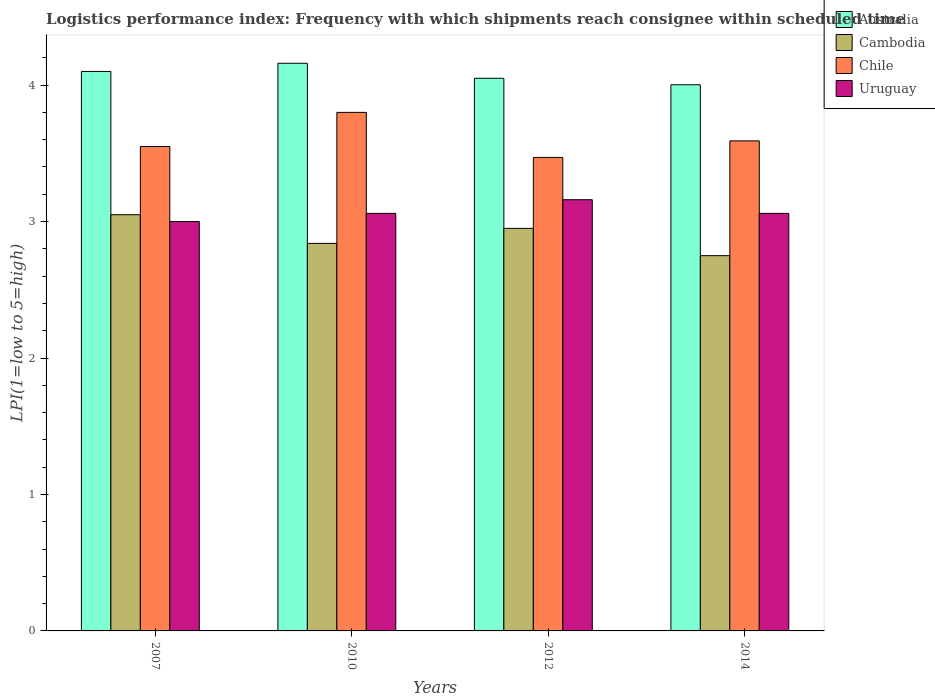How many groups of bars are there?
Provide a short and direct response. 4. Are the number of bars per tick equal to the number of legend labels?
Give a very brief answer. Yes. How many bars are there on the 1st tick from the left?
Your answer should be compact. 4. What is the logistics performance index in Chile in 2007?
Offer a terse response. 3.55. Across all years, what is the maximum logistics performance index in Australia?
Provide a short and direct response. 4.16. Across all years, what is the minimum logistics performance index in Cambodia?
Keep it short and to the point. 2.75. In which year was the logistics performance index in Chile maximum?
Your answer should be very brief. 2010. What is the total logistics performance index in Cambodia in the graph?
Your answer should be compact. 11.59. What is the difference between the logistics performance index in Chile in 2010 and that in 2012?
Ensure brevity in your answer.  0.33. What is the difference between the logistics performance index in Australia in 2007 and the logistics performance index in Chile in 2012?
Provide a succinct answer. 0.63. What is the average logistics performance index in Chile per year?
Make the answer very short. 3.6. In the year 2012, what is the difference between the logistics performance index in Cambodia and logistics performance index in Australia?
Ensure brevity in your answer.  -1.1. In how many years, is the logistics performance index in Chile greater than 1.6?
Give a very brief answer. 4. What is the ratio of the logistics performance index in Australia in 2010 to that in 2014?
Your answer should be very brief. 1.04. Is the logistics performance index in Australia in 2012 less than that in 2014?
Offer a very short reply. No. What is the difference between the highest and the second highest logistics performance index in Uruguay?
Offer a very short reply. 0.1. What is the difference between the highest and the lowest logistics performance index in Cambodia?
Your answer should be compact. 0.3. In how many years, is the logistics performance index in Australia greater than the average logistics performance index in Australia taken over all years?
Your response must be concise. 2. Is it the case that in every year, the sum of the logistics performance index in Cambodia and logistics performance index in Uruguay is greater than the sum of logistics performance index in Australia and logistics performance index in Chile?
Provide a short and direct response. No. What does the 4th bar from the left in 2012 represents?
Provide a succinct answer. Uruguay. What does the 1st bar from the right in 2014 represents?
Ensure brevity in your answer.  Uruguay. How many bars are there?
Ensure brevity in your answer.  16. Are all the bars in the graph horizontal?
Your answer should be compact. No. How many years are there in the graph?
Give a very brief answer. 4. Are the values on the major ticks of Y-axis written in scientific E-notation?
Ensure brevity in your answer.  No. Where does the legend appear in the graph?
Provide a succinct answer. Top right. How are the legend labels stacked?
Give a very brief answer. Vertical. What is the title of the graph?
Keep it short and to the point. Logistics performance index: Frequency with which shipments reach consignee within scheduled time. Does "Lebanon" appear as one of the legend labels in the graph?
Provide a short and direct response. No. What is the label or title of the X-axis?
Keep it short and to the point. Years. What is the label or title of the Y-axis?
Keep it short and to the point. LPI(1=low to 5=high). What is the LPI(1=low to 5=high) of Cambodia in 2007?
Your response must be concise. 3.05. What is the LPI(1=low to 5=high) of Chile in 2007?
Provide a short and direct response. 3.55. What is the LPI(1=low to 5=high) of Australia in 2010?
Ensure brevity in your answer.  4.16. What is the LPI(1=low to 5=high) in Cambodia in 2010?
Your answer should be compact. 2.84. What is the LPI(1=low to 5=high) in Chile in 2010?
Your answer should be compact. 3.8. What is the LPI(1=low to 5=high) of Uruguay in 2010?
Your answer should be compact. 3.06. What is the LPI(1=low to 5=high) in Australia in 2012?
Make the answer very short. 4.05. What is the LPI(1=low to 5=high) in Cambodia in 2012?
Provide a succinct answer. 2.95. What is the LPI(1=low to 5=high) in Chile in 2012?
Your response must be concise. 3.47. What is the LPI(1=low to 5=high) of Uruguay in 2012?
Your response must be concise. 3.16. What is the LPI(1=low to 5=high) in Australia in 2014?
Provide a short and direct response. 4. What is the LPI(1=low to 5=high) in Cambodia in 2014?
Provide a short and direct response. 2.75. What is the LPI(1=low to 5=high) in Chile in 2014?
Keep it short and to the point. 3.59. What is the LPI(1=low to 5=high) of Uruguay in 2014?
Your answer should be very brief. 3.06. Across all years, what is the maximum LPI(1=low to 5=high) in Australia?
Keep it short and to the point. 4.16. Across all years, what is the maximum LPI(1=low to 5=high) of Cambodia?
Your response must be concise. 3.05. Across all years, what is the maximum LPI(1=low to 5=high) of Uruguay?
Make the answer very short. 3.16. Across all years, what is the minimum LPI(1=low to 5=high) in Australia?
Your answer should be very brief. 4. Across all years, what is the minimum LPI(1=low to 5=high) in Cambodia?
Your answer should be compact. 2.75. Across all years, what is the minimum LPI(1=low to 5=high) in Chile?
Ensure brevity in your answer.  3.47. What is the total LPI(1=low to 5=high) of Australia in the graph?
Give a very brief answer. 16.31. What is the total LPI(1=low to 5=high) of Cambodia in the graph?
Give a very brief answer. 11.59. What is the total LPI(1=low to 5=high) in Chile in the graph?
Give a very brief answer. 14.41. What is the total LPI(1=low to 5=high) in Uruguay in the graph?
Give a very brief answer. 12.28. What is the difference between the LPI(1=low to 5=high) in Australia in 2007 and that in 2010?
Make the answer very short. -0.06. What is the difference between the LPI(1=low to 5=high) of Cambodia in 2007 and that in 2010?
Offer a very short reply. 0.21. What is the difference between the LPI(1=low to 5=high) of Chile in 2007 and that in 2010?
Ensure brevity in your answer.  -0.25. What is the difference between the LPI(1=low to 5=high) in Uruguay in 2007 and that in 2010?
Offer a terse response. -0.06. What is the difference between the LPI(1=low to 5=high) in Australia in 2007 and that in 2012?
Offer a very short reply. 0.05. What is the difference between the LPI(1=low to 5=high) in Chile in 2007 and that in 2012?
Ensure brevity in your answer.  0.08. What is the difference between the LPI(1=low to 5=high) of Uruguay in 2007 and that in 2012?
Ensure brevity in your answer.  -0.16. What is the difference between the LPI(1=low to 5=high) of Australia in 2007 and that in 2014?
Give a very brief answer. 0.1. What is the difference between the LPI(1=low to 5=high) of Chile in 2007 and that in 2014?
Your answer should be very brief. -0.04. What is the difference between the LPI(1=low to 5=high) in Uruguay in 2007 and that in 2014?
Ensure brevity in your answer.  -0.06. What is the difference between the LPI(1=low to 5=high) of Australia in 2010 and that in 2012?
Provide a short and direct response. 0.11. What is the difference between the LPI(1=low to 5=high) of Cambodia in 2010 and that in 2012?
Your answer should be very brief. -0.11. What is the difference between the LPI(1=low to 5=high) of Chile in 2010 and that in 2012?
Ensure brevity in your answer.  0.33. What is the difference between the LPI(1=low to 5=high) of Uruguay in 2010 and that in 2012?
Provide a short and direct response. -0.1. What is the difference between the LPI(1=low to 5=high) of Australia in 2010 and that in 2014?
Provide a short and direct response. 0.16. What is the difference between the LPI(1=low to 5=high) of Cambodia in 2010 and that in 2014?
Your answer should be compact. 0.09. What is the difference between the LPI(1=low to 5=high) of Chile in 2010 and that in 2014?
Offer a very short reply. 0.21. What is the difference between the LPI(1=low to 5=high) in Australia in 2012 and that in 2014?
Offer a terse response. 0.05. What is the difference between the LPI(1=low to 5=high) in Chile in 2012 and that in 2014?
Give a very brief answer. -0.12. What is the difference between the LPI(1=low to 5=high) of Uruguay in 2012 and that in 2014?
Offer a terse response. 0.1. What is the difference between the LPI(1=low to 5=high) in Australia in 2007 and the LPI(1=low to 5=high) in Cambodia in 2010?
Your response must be concise. 1.26. What is the difference between the LPI(1=low to 5=high) of Cambodia in 2007 and the LPI(1=low to 5=high) of Chile in 2010?
Your answer should be very brief. -0.75. What is the difference between the LPI(1=low to 5=high) of Cambodia in 2007 and the LPI(1=low to 5=high) of Uruguay in 2010?
Your answer should be compact. -0.01. What is the difference between the LPI(1=low to 5=high) of Chile in 2007 and the LPI(1=low to 5=high) of Uruguay in 2010?
Keep it short and to the point. 0.49. What is the difference between the LPI(1=low to 5=high) of Australia in 2007 and the LPI(1=low to 5=high) of Cambodia in 2012?
Give a very brief answer. 1.15. What is the difference between the LPI(1=low to 5=high) of Australia in 2007 and the LPI(1=low to 5=high) of Chile in 2012?
Provide a succinct answer. 0.63. What is the difference between the LPI(1=low to 5=high) of Australia in 2007 and the LPI(1=low to 5=high) of Uruguay in 2012?
Provide a succinct answer. 0.94. What is the difference between the LPI(1=low to 5=high) in Cambodia in 2007 and the LPI(1=low to 5=high) in Chile in 2012?
Ensure brevity in your answer.  -0.42. What is the difference between the LPI(1=low to 5=high) in Cambodia in 2007 and the LPI(1=low to 5=high) in Uruguay in 2012?
Offer a terse response. -0.11. What is the difference between the LPI(1=low to 5=high) in Chile in 2007 and the LPI(1=low to 5=high) in Uruguay in 2012?
Give a very brief answer. 0.39. What is the difference between the LPI(1=low to 5=high) of Australia in 2007 and the LPI(1=low to 5=high) of Cambodia in 2014?
Offer a terse response. 1.35. What is the difference between the LPI(1=low to 5=high) of Australia in 2007 and the LPI(1=low to 5=high) of Chile in 2014?
Provide a short and direct response. 0.51. What is the difference between the LPI(1=low to 5=high) in Australia in 2007 and the LPI(1=low to 5=high) in Uruguay in 2014?
Your response must be concise. 1.04. What is the difference between the LPI(1=low to 5=high) in Cambodia in 2007 and the LPI(1=low to 5=high) in Chile in 2014?
Give a very brief answer. -0.54. What is the difference between the LPI(1=low to 5=high) in Cambodia in 2007 and the LPI(1=low to 5=high) in Uruguay in 2014?
Keep it short and to the point. -0.01. What is the difference between the LPI(1=low to 5=high) of Chile in 2007 and the LPI(1=low to 5=high) of Uruguay in 2014?
Your answer should be compact. 0.49. What is the difference between the LPI(1=low to 5=high) of Australia in 2010 and the LPI(1=low to 5=high) of Cambodia in 2012?
Keep it short and to the point. 1.21. What is the difference between the LPI(1=low to 5=high) of Australia in 2010 and the LPI(1=low to 5=high) of Chile in 2012?
Ensure brevity in your answer.  0.69. What is the difference between the LPI(1=low to 5=high) in Cambodia in 2010 and the LPI(1=low to 5=high) in Chile in 2012?
Offer a terse response. -0.63. What is the difference between the LPI(1=low to 5=high) of Cambodia in 2010 and the LPI(1=low to 5=high) of Uruguay in 2012?
Give a very brief answer. -0.32. What is the difference between the LPI(1=low to 5=high) in Chile in 2010 and the LPI(1=low to 5=high) in Uruguay in 2012?
Your response must be concise. 0.64. What is the difference between the LPI(1=low to 5=high) in Australia in 2010 and the LPI(1=low to 5=high) in Cambodia in 2014?
Make the answer very short. 1.41. What is the difference between the LPI(1=low to 5=high) of Australia in 2010 and the LPI(1=low to 5=high) of Chile in 2014?
Offer a very short reply. 0.57. What is the difference between the LPI(1=low to 5=high) of Australia in 2010 and the LPI(1=low to 5=high) of Uruguay in 2014?
Offer a very short reply. 1.1. What is the difference between the LPI(1=low to 5=high) in Cambodia in 2010 and the LPI(1=low to 5=high) in Chile in 2014?
Ensure brevity in your answer.  -0.75. What is the difference between the LPI(1=low to 5=high) in Cambodia in 2010 and the LPI(1=low to 5=high) in Uruguay in 2014?
Your answer should be very brief. -0.22. What is the difference between the LPI(1=low to 5=high) in Chile in 2010 and the LPI(1=low to 5=high) in Uruguay in 2014?
Offer a very short reply. 0.74. What is the difference between the LPI(1=low to 5=high) in Australia in 2012 and the LPI(1=low to 5=high) in Chile in 2014?
Give a very brief answer. 0.46. What is the difference between the LPI(1=low to 5=high) in Australia in 2012 and the LPI(1=low to 5=high) in Uruguay in 2014?
Your answer should be compact. 0.99. What is the difference between the LPI(1=low to 5=high) of Cambodia in 2012 and the LPI(1=low to 5=high) of Chile in 2014?
Provide a succinct answer. -0.64. What is the difference between the LPI(1=low to 5=high) in Cambodia in 2012 and the LPI(1=low to 5=high) in Uruguay in 2014?
Ensure brevity in your answer.  -0.11. What is the difference between the LPI(1=low to 5=high) in Chile in 2012 and the LPI(1=low to 5=high) in Uruguay in 2014?
Offer a very short reply. 0.41. What is the average LPI(1=low to 5=high) in Australia per year?
Offer a terse response. 4.08. What is the average LPI(1=low to 5=high) in Cambodia per year?
Provide a short and direct response. 2.9. What is the average LPI(1=low to 5=high) in Chile per year?
Offer a very short reply. 3.6. What is the average LPI(1=low to 5=high) in Uruguay per year?
Your answer should be very brief. 3.07. In the year 2007, what is the difference between the LPI(1=low to 5=high) of Australia and LPI(1=low to 5=high) of Cambodia?
Provide a short and direct response. 1.05. In the year 2007, what is the difference between the LPI(1=low to 5=high) of Australia and LPI(1=low to 5=high) of Chile?
Keep it short and to the point. 0.55. In the year 2007, what is the difference between the LPI(1=low to 5=high) of Cambodia and LPI(1=low to 5=high) of Chile?
Make the answer very short. -0.5. In the year 2007, what is the difference between the LPI(1=low to 5=high) of Cambodia and LPI(1=low to 5=high) of Uruguay?
Make the answer very short. 0.05. In the year 2007, what is the difference between the LPI(1=low to 5=high) in Chile and LPI(1=low to 5=high) in Uruguay?
Make the answer very short. 0.55. In the year 2010, what is the difference between the LPI(1=low to 5=high) in Australia and LPI(1=low to 5=high) in Cambodia?
Offer a terse response. 1.32. In the year 2010, what is the difference between the LPI(1=low to 5=high) in Australia and LPI(1=low to 5=high) in Chile?
Keep it short and to the point. 0.36. In the year 2010, what is the difference between the LPI(1=low to 5=high) of Australia and LPI(1=low to 5=high) of Uruguay?
Provide a succinct answer. 1.1. In the year 2010, what is the difference between the LPI(1=low to 5=high) of Cambodia and LPI(1=low to 5=high) of Chile?
Provide a succinct answer. -0.96. In the year 2010, what is the difference between the LPI(1=low to 5=high) in Cambodia and LPI(1=low to 5=high) in Uruguay?
Your response must be concise. -0.22. In the year 2010, what is the difference between the LPI(1=low to 5=high) in Chile and LPI(1=low to 5=high) in Uruguay?
Offer a terse response. 0.74. In the year 2012, what is the difference between the LPI(1=low to 5=high) of Australia and LPI(1=low to 5=high) of Cambodia?
Offer a terse response. 1.1. In the year 2012, what is the difference between the LPI(1=low to 5=high) of Australia and LPI(1=low to 5=high) of Chile?
Offer a terse response. 0.58. In the year 2012, what is the difference between the LPI(1=low to 5=high) in Australia and LPI(1=low to 5=high) in Uruguay?
Give a very brief answer. 0.89. In the year 2012, what is the difference between the LPI(1=low to 5=high) in Cambodia and LPI(1=low to 5=high) in Chile?
Your answer should be compact. -0.52. In the year 2012, what is the difference between the LPI(1=low to 5=high) in Cambodia and LPI(1=low to 5=high) in Uruguay?
Provide a short and direct response. -0.21. In the year 2012, what is the difference between the LPI(1=low to 5=high) in Chile and LPI(1=low to 5=high) in Uruguay?
Your response must be concise. 0.31. In the year 2014, what is the difference between the LPI(1=low to 5=high) in Australia and LPI(1=low to 5=high) in Cambodia?
Your answer should be compact. 1.25. In the year 2014, what is the difference between the LPI(1=low to 5=high) in Australia and LPI(1=low to 5=high) in Chile?
Offer a terse response. 0.41. In the year 2014, what is the difference between the LPI(1=low to 5=high) of Australia and LPI(1=low to 5=high) of Uruguay?
Ensure brevity in your answer.  0.94. In the year 2014, what is the difference between the LPI(1=low to 5=high) in Cambodia and LPI(1=low to 5=high) in Chile?
Ensure brevity in your answer.  -0.84. In the year 2014, what is the difference between the LPI(1=low to 5=high) in Cambodia and LPI(1=low to 5=high) in Uruguay?
Provide a short and direct response. -0.31. In the year 2014, what is the difference between the LPI(1=low to 5=high) in Chile and LPI(1=low to 5=high) in Uruguay?
Keep it short and to the point. 0.53. What is the ratio of the LPI(1=low to 5=high) in Australia in 2007 to that in 2010?
Offer a terse response. 0.99. What is the ratio of the LPI(1=low to 5=high) of Cambodia in 2007 to that in 2010?
Provide a succinct answer. 1.07. What is the ratio of the LPI(1=low to 5=high) in Chile in 2007 to that in 2010?
Your response must be concise. 0.93. What is the ratio of the LPI(1=low to 5=high) in Uruguay in 2007 to that in 2010?
Your answer should be very brief. 0.98. What is the ratio of the LPI(1=low to 5=high) of Australia in 2007 to that in 2012?
Give a very brief answer. 1.01. What is the ratio of the LPI(1=low to 5=high) of Cambodia in 2007 to that in 2012?
Give a very brief answer. 1.03. What is the ratio of the LPI(1=low to 5=high) in Chile in 2007 to that in 2012?
Your answer should be compact. 1.02. What is the ratio of the LPI(1=low to 5=high) of Uruguay in 2007 to that in 2012?
Provide a short and direct response. 0.95. What is the ratio of the LPI(1=low to 5=high) of Australia in 2007 to that in 2014?
Provide a succinct answer. 1.02. What is the ratio of the LPI(1=low to 5=high) in Cambodia in 2007 to that in 2014?
Give a very brief answer. 1.11. What is the ratio of the LPI(1=low to 5=high) of Uruguay in 2007 to that in 2014?
Provide a succinct answer. 0.98. What is the ratio of the LPI(1=low to 5=high) in Australia in 2010 to that in 2012?
Provide a succinct answer. 1.03. What is the ratio of the LPI(1=low to 5=high) of Cambodia in 2010 to that in 2012?
Make the answer very short. 0.96. What is the ratio of the LPI(1=low to 5=high) of Chile in 2010 to that in 2012?
Your answer should be very brief. 1.1. What is the ratio of the LPI(1=low to 5=high) of Uruguay in 2010 to that in 2012?
Offer a very short reply. 0.97. What is the ratio of the LPI(1=low to 5=high) in Australia in 2010 to that in 2014?
Give a very brief answer. 1.04. What is the ratio of the LPI(1=low to 5=high) of Cambodia in 2010 to that in 2014?
Ensure brevity in your answer.  1.03. What is the ratio of the LPI(1=low to 5=high) of Chile in 2010 to that in 2014?
Offer a very short reply. 1.06. What is the ratio of the LPI(1=low to 5=high) in Uruguay in 2010 to that in 2014?
Offer a very short reply. 1. What is the ratio of the LPI(1=low to 5=high) in Australia in 2012 to that in 2014?
Keep it short and to the point. 1.01. What is the ratio of the LPI(1=low to 5=high) of Cambodia in 2012 to that in 2014?
Ensure brevity in your answer.  1.07. What is the ratio of the LPI(1=low to 5=high) in Chile in 2012 to that in 2014?
Your answer should be compact. 0.97. What is the ratio of the LPI(1=low to 5=high) of Uruguay in 2012 to that in 2014?
Offer a very short reply. 1.03. What is the difference between the highest and the second highest LPI(1=low to 5=high) of Australia?
Provide a succinct answer. 0.06. What is the difference between the highest and the second highest LPI(1=low to 5=high) of Cambodia?
Provide a succinct answer. 0.1. What is the difference between the highest and the second highest LPI(1=low to 5=high) of Chile?
Your response must be concise. 0.21. What is the difference between the highest and the lowest LPI(1=low to 5=high) of Australia?
Make the answer very short. 0.16. What is the difference between the highest and the lowest LPI(1=low to 5=high) of Chile?
Your response must be concise. 0.33. What is the difference between the highest and the lowest LPI(1=low to 5=high) in Uruguay?
Offer a terse response. 0.16. 